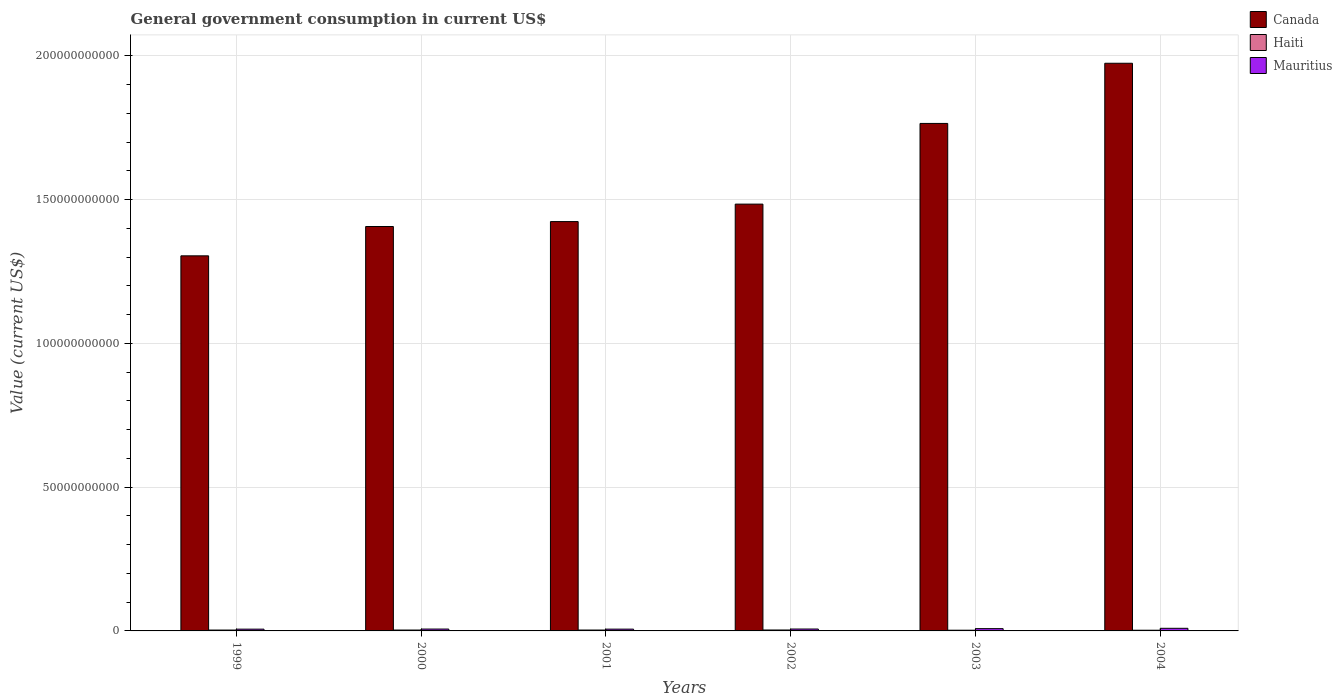How many different coloured bars are there?
Your answer should be compact. 3. How many groups of bars are there?
Give a very brief answer. 6. What is the label of the 2nd group of bars from the left?
Make the answer very short. 2000. In how many cases, is the number of bars for a given year not equal to the number of legend labels?
Provide a short and direct response. 0. What is the government conusmption in Mauritius in 2000?
Provide a succinct answer. 6.47e+08. Across all years, what is the maximum government conusmption in Mauritius?
Your answer should be compact. 9.11e+08. Across all years, what is the minimum government conusmption in Mauritius?
Your answer should be very brief. 6.15e+08. In which year was the government conusmption in Mauritius maximum?
Give a very brief answer. 2004. What is the total government conusmption in Canada in the graph?
Your answer should be very brief. 9.36e+11. What is the difference between the government conusmption in Canada in 2000 and that in 2002?
Give a very brief answer. -7.79e+09. What is the difference between the government conusmption in Canada in 2000 and the government conusmption in Haiti in 2002?
Ensure brevity in your answer.  1.40e+11. What is the average government conusmption in Mauritius per year?
Your answer should be very brief. 7.10e+08. In the year 1999, what is the difference between the government conusmption in Canada and government conusmption in Haiti?
Provide a short and direct response. 1.30e+11. In how many years, is the government conusmption in Haiti greater than 130000000000 US$?
Ensure brevity in your answer.  0. What is the ratio of the government conusmption in Canada in 2000 to that in 2004?
Offer a very short reply. 0.71. What is the difference between the highest and the second highest government conusmption in Haiti?
Your answer should be very brief. 1.25e+07. What is the difference between the highest and the lowest government conusmption in Mauritius?
Ensure brevity in your answer.  2.96e+08. What does the 2nd bar from the left in 1999 represents?
Your response must be concise. Haiti. What does the 2nd bar from the right in 2000 represents?
Offer a very short reply. Haiti. How many bars are there?
Give a very brief answer. 18. Are the values on the major ticks of Y-axis written in scientific E-notation?
Ensure brevity in your answer.  No. Does the graph contain grids?
Give a very brief answer. Yes. How many legend labels are there?
Offer a very short reply. 3. What is the title of the graph?
Offer a terse response. General government consumption in current US$. Does "Brazil" appear as one of the legend labels in the graph?
Offer a terse response. No. What is the label or title of the Y-axis?
Your answer should be very brief. Value (current US$). What is the Value (current US$) of Canada in 1999?
Keep it short and to the point. 1.30e+11. What is the Value (current US$) of Haiti in 1999?
Make the answer very short. 3.02e+08. What is the Value (current US$) in Mauritius in 1999?
Keep it short and to the point. 6.15e+08. What is the Value (current US$) in Canada in 2000?
Make the answer very short. 1.41e+11. What is the Value (current US$) of Haiti in 2000?
Make the answer very short. 3.09e+08. What is the Value (current US$) in Mauritius in 2000?
Provide a succinct answer. 6.47e+08. What is the Value (current US$) of Canada in 2001?
Provide a succinct answer. 1.42e+11. What is the Value (current US$) of Haiti in 2001?
Keep it short and to the point. 3.09e+08. What is the Value (current US$) in Mauritius in 2001?
Ensure brevity in your answer.  6.25e+08. What is the Value (current US$) in Canada in 2002?
Provide a short and direct response. 1.48e+11. What is the Value (current US$) in Haiti in 2002?
Your answer should be very brief. 3.22e+08. What is the Value (current US$) in Mauritius in 2002?
Keep it short and to the point. 6.63e+08. What is the Value (current US$) in Canada in 2003?
Make the answer very short. 1.77e+11. What is the Value (current US$) of Haiti in 2003?
Keep it short and to the point. 2.46e+08. What is the Value (current US$) in Mauritius in 2003?
Your answer should be compact. 7.98e+08. What is the Value (current US$) in Canada in 2004?
Ensure brevity in your answer.  1.97e+11. What is the Value (current US$) of Haiti in 2004?
Provide a short and direct response. 2.40e+08. What is the Value (current US$) of Mauritius in 2004?
Provide a short and direct response. 9.11e+08. Across all years, what is the maximum Value (current US$) of Canada?
Your answer should be very brief. 1.97e+11. Across all years, what is the maximum Value (current US$) in Haiti?
Ensure brevity in your answer.  3.22e+08. Across all years, what is the maximum Value (current US$) in Mauritius?
Your response must be concise. 9.11e+08. Across all years, what is the minimum Value (current US$) of Canada?
Offer a very short reply. 1.30e+11. Across all years, what is the minimum Value (current US$) of Haiti?
Give a very brief answer. 2.40e+08. Across all years, what is the minimum Value (current US$) of Mauritius?
Make the answer very short. 6.15e+08. What is the total Value (current US$) of Canada in the graph?
Provide a succinct answer. 9.36e+11. What is the total Value (current US$) in Haiti in the graph?
Provide a short and direct response. 1.73e+09. What is the total Value (current US$) of Mauritius in the graph?
Your answer should be very brief. 4.26e+09. What is the difference between the Value (current US$) in Canada in 1999 and that in 2000?
Make the answer very short. -1.02e+1. What is the difference between the Value (current US$) in Haiti in 1999 and that in 2000?
Your response must be concise. -6.99e+06. What is the difference between the Value (current US$) of Mauritius in 1999 and that in 2000?
Make the answer very short. -3.23e+07. What is the difference between the Value (current US$) in Canada in 1999 and that in 2001?
Make the answer very short. -1.19e+1. What is the difference between the Value (current US$) of Haiti in 1999 and that in 2001?
Your answer should be compact. -7.09e+06. What is the difference between the Value (current US$) in Mauritius in 1999 and that in 2001?
Provide a succinct answer. -9.83e+06. What is the difference between the Value (current US$) in Canada in 1999 and that in 2002?
Your answer should be compact. -1.80e+1. What is the difference between the Value (current US$) in Haiti in 1999 and that in 2002?
Ensure brevity in your answer.  -1.96e+07. What is the difference between the Value (current US$) of Mauritius in 1999 and that in 2002?
Offer a terse response. -4.78e+07. What is the difference between the Value (current US$) in Canada in 1999 and that in 2003?
Your response must be concise. -4.61e+1. What is the difference between the Value (current US$) of Haiti in 1999 and that in 2003?
Offer a terse response. 5.60e+07. What is the difference between the Value (current US$) of Mauritius in 1999 and that in 2003?
Your answer should be compact. -1.83e+08. What is the difference between the Value (current US$) in Canada in 1999 and that in 2004?
Give a very brief answer. -6.70e+1. What is the difference between the Value (current US$) in Haiti in 1999 and that in 2004?
Your answer should be very brief. 6.18e+07. What is the difference between the Value (current US$) in Mauritius in 1999 and that in 2004?
Ensure brevity in your answer.  -2.96e+08. What is the difference between the Value (current US$) of Canada in 2000 and that in 2001?
Make the answer very short. -1.71e+09. What is the difference between the Value (current US$) in Haiti in 2000 and that in 2001?
Your response must be concise. -1.00e+05. What is the difference between the Value (current US$) of Mauritius in 2000 and that in 2001?
Your response must be concise. 2.24e+07. What is the difference between the Value (current US$) of Canada in 2000 and that in 2002?
Offer a terse response. -7.79e+09. What is the difference between the Value (current US$) in Haiti in 2000 and that in 2002?
Offer a very short reply. -1.26e+07. What is the difference between the Value (current US$) in Mauritius in 2000 and that in 2002?
Provide a succinct answer. -1.56e+07. What is the difference between the Value (current US$) in Canada in 2000 and that in 2003?
Make the answer very short. -3.58e+1. What is the difference between the Value (current US$) of Haiti in 2000 and that in 2003?
Provide a succinct answer. 6.30e+07. What is the difference between the Value (current US$) of Mauritius in 2000 and that in 2003?
Ensure brevity in your answer.  -1.51e+08. What is the difference between the Value (current US$) in Canada in 2000 and that in 2004?
Offer a very short reply. -5.68e+1. What is the difference between the Value (current US$) of Haiti in 2000 and that in 2004?
Offer a terse response. 6.87e+07. What is the difference between the Value (current US$) of Mauritius in 2000 and that in 2004?
Give a very brief answer. -2.64e+08. What is the difference between the Value (current US$) in Canada in 2001 and that in 2002?
Keep it short and to the point. -6.08e+09. What is the difference between the Value (current US$) in Haiti in 2001 and that in 2002?
Offer a terse response. -1.25e+07. What is the difference between the Value (current US$) of Mauritius in 2001 and that in 2002?
Your response must be concise. -3.80e+07. What is the difference between the Value (current US$) of Canada in 2001 and that in 2003?
Keep it short and to the point. -3.41e+1. What is the difference between the Value (current US$) of Haiti in 2001 and that in 2003?
Your answer should be compact. 6.31e+07. What is the difference between the Value (current US$) in Mauritius in 2001 and that in 2003?
Your answer should be compact. -1.74e+08. What is the difference between the Value (current US$) in Canada in 2001 and that in 2004?
Give a very brief answer. -5.51e+1. What is the difference between the Value (current US$) of Haiti in 2001 and that in 2004?
Make the answer very short. 6.88e+07. What is the difference between the Value (current US$) of Mauritius in 2001 and that in 2004?
Your answer should be very brief. -2.86e+08. What is the difference between the Value (current US$) in Canada in 2002 and that in 2003?
Your answer should be compact. -2.81e+1. What is the difference between the Value (current US$) of Haiti in 2002 and that in 2003?
Offer a terse response. 7.56e+07. What is the difference between the Value (current US$) of Mauritius in 2002 and that in 2003?
Your answer should be compact. -1.36e+08. What is the difference between the Value (current US$) of Canada in 2002 and that in 2004?
Offer a very short reply. -4.90e+1. What is the difference between the Value (current US$) in Haiti in 2002 and that in 2004?
Provide a succinct answer. 8.14e+07. What is the difference between the Value (current US$) in Mauritius in 2002 and that in 2004?
Make the answer very short. -2.48e+08. What is the difference between the Value (current US$) in Canada in 2003 and that in 2004?
Offer a very short reply. -2.09e+1. What is the difference between the Value (current US$) in Haiti in 2003 and that in 2004?
Provide a succinct answer. 5.73e+06. What is the difference between the Value (current US$) in Mauritius in 2003 and that in 2004?
Provide a succinct answer. -1.12e+08. What is the difference between the Value (current US$) in Canada in 1999 and the Value (current US$) in Haiti in 2000?
Give a very brief answer. 1.30e+11. What is the difference between the Value (current US$) of Canada in 1999 and the Value (current US$) of Mauritius in 2000?
Provide a short and direct response. 1.30e+11. What is the difference between the Value (current US$) in Haiti in 1999 and the Value (current US$) in Mauritius in 2000?
Give a very brief answer. -3.45e+08. What is the difference between the Value (current US$) in Canada in 1999 and the Value (current US$) in Haiti in 2001?
Make the answer very short. 1.30e+11. What is the difference between the Value (current US$) of Canada in 1999 and the Value (current US$) of Mauritius in 2001?
Offer a terse response. 1.30e+11. What is the difference between the Value (current US$) of Haiti in 1999 and the Value (current US$) of Mauritius in 2001?
Keep it short and to the point. -3.23e+08. What is the difference between the Value (current US$) in Canada in 1999 and the Value (current US$) in Haiti in 2002?
Make the answer very short. 1.30e+11. What is the difference between the Value (current US$) in Canada in 1999 and the Value (current US$) in Mauritius in 2002?
Provide a succinct answer. 1.30e+11. What is the difference between the Value (current US$) in Haiti in 1999 and the Value (current US$) in Mauritius in 2002?
Ensure brevity in your answer.  -3.61e+08. What is the difference between the Value (current US$) in Canada in 1999 and the Value (current US$) in Haiti in 2003?
Your response must be concise. 1.30e+11. What is the difference between the Value (current US$) of Canada in 1999 and the Value (current US$) of Mauritius in 2003?
Your answer should be compact. 1.30e+11. What is the difference between the Value (current US$) of Haiti in 1999 and the Value (current US$) of Mauritius in 2003?
Your response must be concise. -4.96e+08. What is the difference between the Value (current US$) in Canada in 1999 and the Value (current US$) in Haiti in 2004?
Provide a short and direct response. 1.30e+11. What is the difference between the Value (current US$) in Canada in 1999 and the Value (current US$) in Mauritius in 2004?
Make the answer very short. 1.30e+11. What is the difference between the Value (current US$) in Haiti in 1999 and the Value (current US$) in Mauritius in 2004?
Make the answer very short. -6.09e+08. What is the difference between the Value (current US$) of Canada in 2000 and the Value (current US$) of Haiti in 2001?
Make the answer very short. 1.40e+11. What is the difference between the Value (current US$) in Canada in 2000 and the Value (current US$) in Mauritius in 2001?
Make the answer very short. 1.40e+11. What is the difference between the Value (current US$) of Haiti in 2000 and the Value (current US$) of Mauritius in 2001?
Your response must be concise. -3.16e+08. What is the difference between the Value (current US$) in Canada in 2000 and the Value (current US$) in Haiti in 2002?
Make the answer very short. 1.40e+11. What is the difference between the Value (current US$) in Canada in 2000 and the Value (current US$) in Mauritius in 2002?
Provide a short and direct response. 1.40e+11. What is the difference between the Value (current US$) in Haiti in 2000 and the Value (current US$) in Mauritius in 2002?
Your answer should be very brief. -3.54e+08. What is the difference between the Value (current US$) of Canada in 2000 and the Value (current US$) of Haiti in 2003?
Your answer should be compact. 1.40e+11. What is the difference between the Value (current US$) in Canada in 2000 and the Value (current US$) in Mauritius in 2003?
Provide a succinct answer. 1.40e+11. What is the difference between the Value (current US$) in Haiti in 2000 and the Value (current US$) in Mauritius in 2003?
Ensure brevity in your answer.  -4.89e+08. What is the difference between the Value (current US$) in Canada in 2000 and the Value (current US$) in Haiti in 2004?
Offer a terse response. 1.40e+11. What is the difference between the Value (current US$) in Canada in 2000 and the Value (current US$) in Mauritius in 2004?
Provide a succinct answer. 1.40e+11. What is the difference between the Value (current US$) of Haiti in 2000 and the Value (current US$) of Mauritius in 2004?
Offer a very short reply. -6.02e+08. What is the difference between the Value (current US$) in Canada in 2001 and the Value (current US$) in Haiti in 2002?
Make the answer very short. 1.42e+11. What is the difference between the Value (current US$) of Canada in 2001 and the Value (current US$) of Mauritius in 2002?
Offer a terse response. 1.42e+11. What is the difference between the Value (current US$) of Haiti in 2001 and the Value (current US$) of Mauritius in 2002?
Offer a terse response. -3.53e+08. What is the difference between the Value (current US$) in Canada in 2001 and the Value (current US$) in Haiti in 2003?
Provide a succinct answer. 1.42e+11. What is the difference between the Value (current US$) in Canada in 2001 and the Value (current US$) in Mauritius in 2003?
Your answer should be very brief. 1.42e+11. What is the difference between the Value (current US$) of Haiti in 2001 and the Value (current US$) of Mauritius in 2003?
Keep it short and to the point. -4.89e+08. What is the difference between the Value (current US$) of Canada in 2001 and the Value (current US$) of Haiti in 2004?
Your answer should be compact. 1.42e+11. What is the difference between the Value (current US$) in Canada in 2001 and the Value (current US$) in Mauritius in 2004?
Offer a terse response. 1.41e+11. What is the difference between the Value (current US$) in Haiti in 2001 and the Value (current US$) in Mauritius in 2004?
Your response must be concise. -6.01e+08. What is the difference between the Value (current US$) in Canada in 2002 and the Value (current US$) in Haiti in 2003?
Keep it short and to the point. 1.48e+11. What is the difference between the Value (current US$) in Canada in 2002 and the Value (current US$) in Mauritius in 2003?
Make the answer very short. 1.48e+11. What is the difference between the Value (current US$) of Haiti in 2002 and the Value (current US$) of Mauritius in 2003?
Offer a very short reply. -4.77e+08. What is the difference between the Value (current US$) in Canada in 2002 and the Value (current US$) in Haiti in 2004?
Your response must be concise. 1.48e+11. What is the difference between the Value (current US$) of Canada in 2002 and the Value (current US$) of Mauritius in 2004?
Make the answer very short. 1.48e+11. What is the difference between the Value (current US$) in Haiti in 2002 and the Value (current US$) in Mauritius in 2004?
Provide a short and direct response. -5.89e+08. What is the difference between the Value (current US$) in Canada in 2003 and the Value (current US$) in Haiti in 2004?
Provide a succinct answer. 1.76e+11. What is the difference between the Value (current US$) of Canada in 2003 and the Value (current US$) of Mauritius in 2004?
Provide a succinct answer. 1.76e+11. What is the difference between the Value (current US$) of Haiti in 2003 and the Value (current US$) of Mauritius in 2004?
Keep it short and to the point. -6.65e+08. What is the average Value (current US$) in Canada per year?
Your response must be concise. 1.56e+11. What is the average Value (current US$) in Haiti per year?
Keep it short and to the point. 2.88e+08. What is the average Value (current US$) of Mauritius per year?
Make the answer very short. 7.10e+08. In the year 1999, what is the difference between the Value (current US$) in Canada and Value (current US$) in Haiti?
Your response must be concise. 1.30e+11. In the year 1999, what is the difference between the Value (current US$) in Canada and Value (current US$) in Mauritius?
Ensure brevity in your answer.  1.30e+11. In the year 1999, what is the difference between the Value (current US$) in Haiti and Value (current US$) in Mauritius?
Your answer should be compact. -3.13e+08. In the year 2000, what is the difference between the Value (current US$) of Canada and Value (current US$) of Haiti?
Provide a short and direct response. 1.40e+11. In the year 2000, what is the difference between the Value (current US$) in Canada and Value (current US$) in Mauritius?
Your answer should be very brief. 1.40e+11. In the year 2000, what is the difference between the Value (current US$) of Haiti and Value (current US$) of Mauritius?
Keep it short and to the point. -3.38e+08. In the year 2001, what is the difference between the Value (current US$) of Canada and Value (current US$) of Haiti?
Your answer should be compact. 1.42e+11. In the year 2001, what is the difference between the Value (current US$) of Canada and Value (current US$) of Mauritius?
Your answer should be compact. 1.42e+11. In the year 2001, what is the difference between the Value (current US$) of Haiti and Value (current US$) of Mauritius?
Your answer should be compact. -3.15e+08. In the year 2002, what is the difference between the Value (current US$) in Canada and Value (current US$) in Haiti?
Give a very brief answer. 1.48e+11. In the year 2002, what is the difference between the Value (current US$) in Canada and Value (current US$) in Mauritius?
Offer a terse response. 1.48e+11. In the year 2002, what is the difference between the Value (current US$) in Haiti and Value (current US$) in Mauritius?
Your answer should be compact. -3.41e+08. In the year 2003, what is the difference between the Value (current US$) of Canada and Value (current US$) of Haiti?
Your answer should be compact. 1.76e+11. In the year 2003, what is the difference between the Value (current US$) of Canada and Value (current US$) of Mauritius?
Give a very brief answer. 1.76e+11. In the year 2003, what is the difference between the Value (current US$) in Haiti and Value (current US$) in Mauritius?
Your answer should be very brief. -5.52e+08. In the year 2004, what is the difference between the Value (current US$) of Canada and Value (current US$) of Haiti?
Offer a very short reply. 1.97e+11. In the year 2004, what is the difference between the Value (current US$) of Canada and Value (current US$) of Mauritius?
Offer a terse response. 1.97e+11. In the year 2004, what is the difference between the Value (current US$) in Haiti and Value (current US$) in Mauritius?
Keep it short and to the point. -6.70e+08. What is the ratio of the Value (current US$) of Canada in 1999 to that in 2000?
Give a very brief answer. 0.93. What is the ratio of the Value (current US$) of Haiti in 1999 to that in 2000?
Offer a terse response. 0.98. What is the ratio of the Value (current US$) in Mauritius in 1999 to that in 2000?
Your response must be concise. 0.95. What is the ratio of the Value (current US$) in Canada in 1999 to that in 2001?
Make the answer very short. 0.92. What is the ratio of the Value (current US$) of Haiti in 1999 to that in 2001?
Ensure brevity in your answer.  0.98. What is the ratio of the Value (current US$) of Mauritius in 1999 to that in 2001?
Ensure brevity in your answer.  0.98. What is the ratio of the Value (current US$) in Canada in 1999 to that in 2002?
Give a very brief answer. 0.88. What is the ratio of the Value (current US$) in Haiti in 1999 to that in 2002?
Your answer should be very brief. 0.94. What is the ratio of the Value (current US$) in Mauritius in 1999 to that in 2002?
Your response must be concise. 0.93. What is the ratio of the Value (current US$) of Canada in 1999 to that in 2003?
Keep it short and to the point. 0.74. What is the ratio of the Value (current US$) in Haiti in 1999 to that in 2003?
Your answer should be compact. 1.23. What is the ratio of the Value (current US$) in Mauritius in 1999 to that in 2003?
Ensure brevity in your answer.  0.77. What is the ratio of the Value (current US$) in Canada in 1999 to that in 2004?
Offer a terse response. 0.66. What is the ratio of the Value (current US$) in Haiti in 1999 to that in 2004?
Provide a succinct answer. 1.26. What is the ratio of the Value (current US$) of Mauritius in 1999 to that in 2004?
Keep it short and to the point. 0.68. What is the ratio of the Value (current US$) in Canada in 2000 to that in 2001?
Provide a short and direct response. 0.99. What is the ratio of the Value (current US$) of Haiti in 2000 to that in 2001?
Keep it short and to the point. 1. What is the ratio of the Value (current US$) of Mauritius in 2000 to that in 2001?
Ensure brevity in your answer.  1.04. What is the ratio of the Value (current US$) in Canada in 2000 to that in 2002?
Offer a terse response. 0.95. What is the ratio of the Value (current US$) of Haiti in 2000 to that in 2002?
Your answer should be compact. 0.96. What is the ratio of the Value (current US$) of Mauritius in 2000 to that in 2002?
Give a very brief answer. 0.98. What is the ratio of the Value (current US$) of Canada in 2000 to that in 2003?
Keep it short and to the point. 0.8. What is the ratio of the Value (current US$) of Haiti in 2000 to that in 2003?
Ensure brevity in your answer.  1.26. What is the ratio of the Value (current US$) of Mauritius in 2000 to that in 2003?
Give a very brief answer. 0.81. What is the ratio of the Value (current US$) of Canada in 2000 to that in 2004?
Give a very brief answer. 0.71. What is the ratio of the Value (current US$) in Haiti in 2000 to that in 2004?
Ensure brevity in your answer.  1.29. What is the ratio of the Value (current US$) of Mauritius in 2000 to that in 2004?
Provide a succinct answer. 0.71. What is the ratio of the Value (current US$) in Canada in 2001 to that in 2002?
Make the answer very short. 0.96. What is the ratio of the Value (current US$) in Haiti in 2001 to that in 2002?
Offer a very short reply. 0.96. What is the ratio of the Value (current US$) in Mauritius in 2001 to that in 2002?
Make the answer very short. 0.94. What is the ratio of the Value (current US$) in Canada in 2001 to that in 2003?
Offer a terse response. 0.81. What is the ratio of the Value (current US$) of Haiti in 2001 to that in 2003?
Your answer should be compact. 1.26. What is the ratio of the Value (current US$) in Mauritius in 2001 to that in 2003?
Ensure brevity in your answer.  0.78. What is the ratio of the Value (current US$) of Canada in 2001 to that in 2004?
Provide a short and direct response. 0.72. What is the ratio of the Value (current US$) in Haiti in 2001 to that in 2004?
Make the answer very short. 1.29. What is the ratio of the Value (current US$) in Mauritius in 2001 to that in 2004?
Give a very brief answer. 0.69. What is the ratio of the Value (current US$) of Canada in 2002 to that in 2003?
Make the answer very short. 0.84. What is the ratio of the Value (current US$) in Haiti in 2002 to that in 2003?
Provide a short and direct response. 1.31. What is the ratio of the Value (current US$) of Mauritius in 2002 to that in 2003?
Your answer should be compact. 0.83. What is the ratio of the Value (current US$) in Canada in 2002 to that in 2004?
Make the answer very short. 0.75. What is the ratio of the Value (current US$) in Haiti in 2002 to that in 2004?
Give a very brief answer. 1.34. What is the ratio of the Value (current US$) in Mauritius in 2002 to that in 2004?
Your answer should be very brief. 0.73. What is the ratio of the Value (current US$) of Canada in 2003 to that in 2004?
Your answer should be very brief. 0.89. What is the ratio of the Value (current US$) of Haiti in 2003 to that in 2004?
Provide a succinct answer. 1.02. What is the ratio of the Value (current US$) of Mauritius in 2003 to that in 2004?
Make the answer very short. 0.88. What is the difference between the highest and the second highest Value (current US$) of Canada?
Provide a succinct answer. 2.09e+1. What is the difference between the highest and the second highest Value (current US$) of Haiti?
Offer a terse response. 1.25e+07. What is the difference between the highest and the second highest Value (current US$) of Mauritius?
Offer a very short reply. 1.12e+08. What is the difference between the highest and the lowest Value (current US$) of Canada?
Offer a very short reply. 6.70e+1. What is the difference between the highest and the lowest Value (current US$) of Haiti?
Provide a succinct answer. 8.14e+07. What is the difference between the highest and the lowest Value (current US$) of Mauritius?
Offer a terse response. 2.96e+08. 